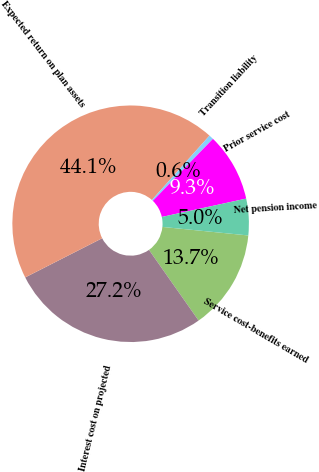<chart> <loc_0><loc_0><loc_500><loc_500><pie_chart><fcel>Service cost-benefits earned<fcel>Interest cost on projected<fcel>Expected return on plan assets<fcel>Transition liability<fcel>Prior service cost<fcel>Net pension income<nl><fcel>13.68%<fcel>27.25%<fcel>44.11%<fcel>0.64%<fcel>9.33%<fcel>4.99%<nl></chart> 